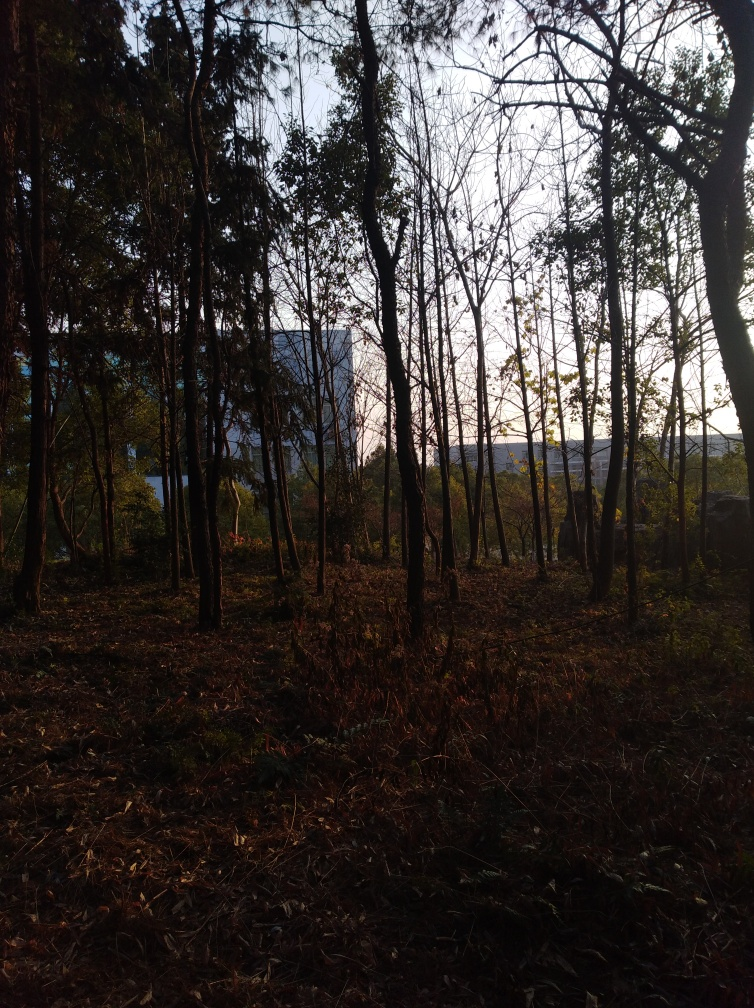Does the photograph suffer from noise/distortion?
A. Yes
B. No
Answer with the option's letter from the given choices directly.
 B. 